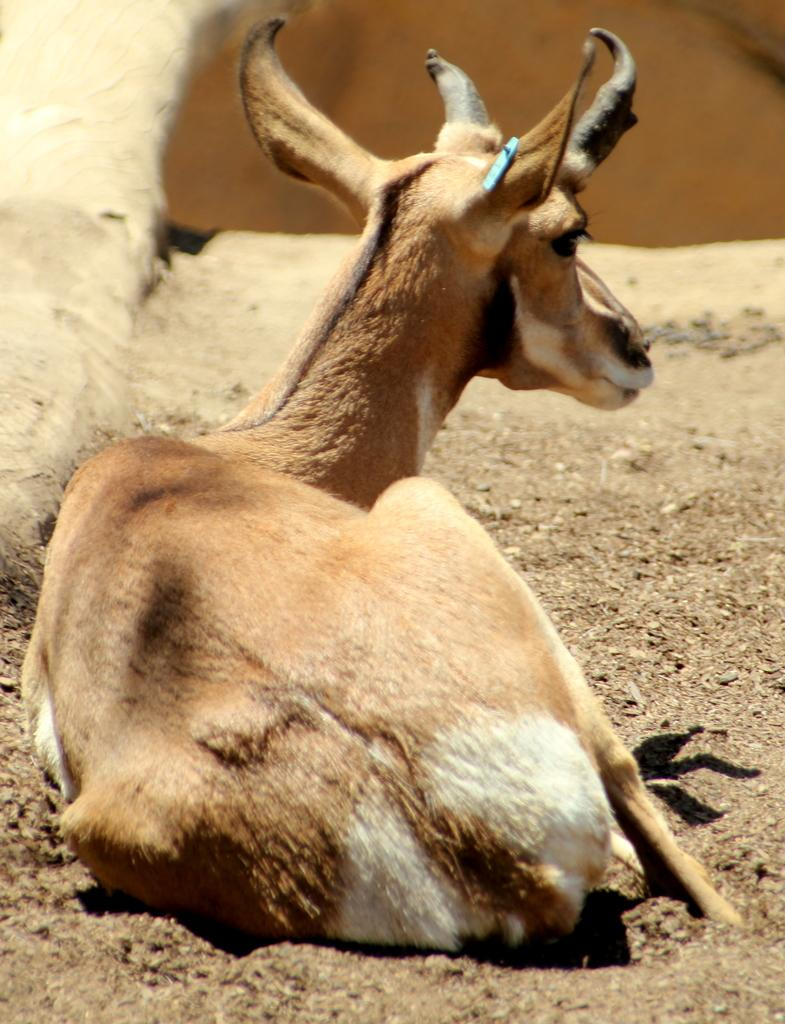What type of creature can be seen in the image? There is an animal in the image. Where is the animal located in the image? The animal is sitting on the ground. Can you describe the background of the image? The background of the image is blurry. What type of jelly can be seen on the stove in the image? There is no stove or jelly present in the image; it features an animal sitting on the ground with a blurry background. 